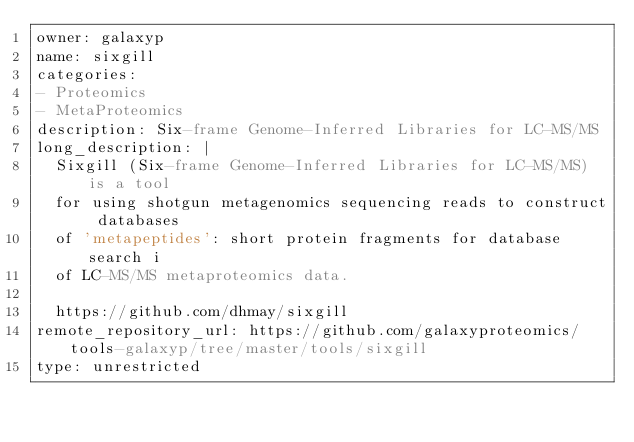Convert code to text. <code><loc_0><loc_0><loc_500><loc_500><_YAML_>owner: galaxyp
name: sixgill
categories:
- Proteomics
- MetaProteomics
description: Six-frame Genome-Inferred Libraries for LC-MS/MS
long_description: |
  Sixgill (Six-frame Genome-Inferred Libraries for LC-MS/MS) is a tool 
  for using shotgun metagenomics sequencing reads to construct databases 
  of 'metapeptides': short protein fragments for database search i
  of LC-MS/MS metaproteomics data.

  https://github.com/dhmay/sixgill
remote_repository_url: https://github.com/galaxyproteomics/tools-galaxyp/tree/master/tools/sixgill
type: unrestricted
</code> 